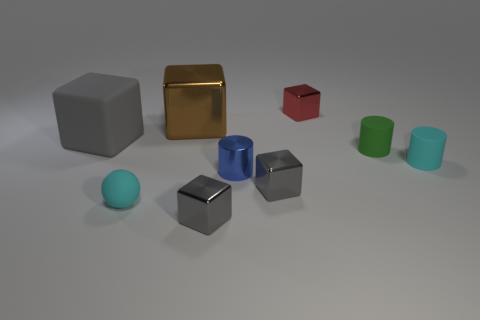There is a thing that is behind the small cyan rubber ball and on the left side of the brown object; what is its material?
Your answer should be very brief. Rubber. Are there an equal number of small metal blocks left of the small cyan rubber sphere and big brown matte cubes?
Offer a very short reply. Yes. What number of large purple metal things are the same shape as the tiny green thing?
Your answer should be compact. 0. What is the size of the cyan rubber thing to the left of the small cyan object on the right side of the small cyan rubber object that is to the left of the green thing?
Provide a succinct answer. Small. Is the small cyan object right of the brown metallic thing made of the same material as the big brown block?
Provide a short and direct response. No. Are there the same number of tiny cyan cylinders that are behind the cyan cylinder and cyan objects that are behind the brown cube?
Ensure brevity in your answer.  Yes. Is there anything else that is the same size as the cyan cylinder?
Make the answer very short. Yes. What material is the other large object that is the same shape as the big metallic thing?
Your response must be concise. Rubber. There is a small cylinder that is to the left of the small cube that is behind the big rubber object; are there any cubes that are in front of it?
Your answer should be very brief. Yes. There is a tiny cyan thing that is on the right side of the small red block; does it have the same shape as the small rubber object that is to the left of the tiny green cylinder?
Your response must be concise. No. 